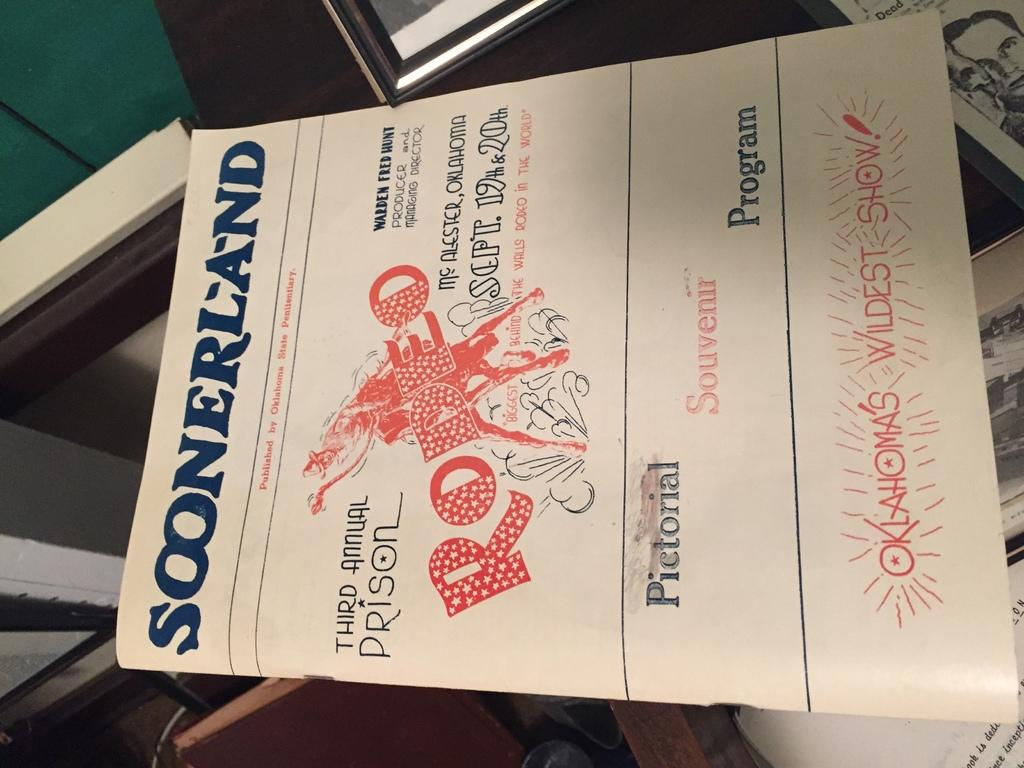<image>
Write a terse but informative summary of the picture. A pictorial program says that Soonerland is published by the Oklahoma State Penitentiary. 